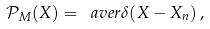Convert formula to latex. <formula><loc_0><loc_0><loc_500><loc_500>\mathcal { P } _ { M } ( X ) = \ a v e r { \delta ( X - X _ { n } ) } \, ,</formula> 